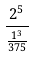<formula> <loc_0><loc_0><loc_500><loc_500>\frac { 2 ^ { 5 } } { \frac { 1 ^ { 3 } } { 3 7 5 } }</formula> 